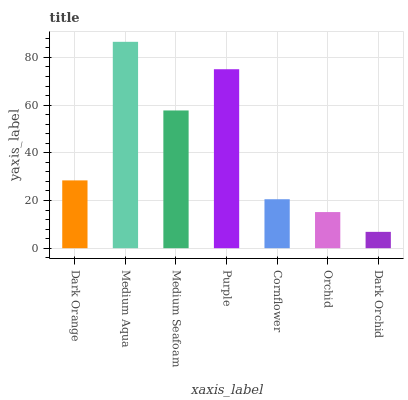Is Dark Orchid the minimum?
Answer yes or no. Yes. Is Medium Aqua the maximum?
Answer yes or no. Yes. Is Medium Seafoam the minimum?
Answer yes or no. No. Is Medium Seafoam the maximum?
Answer yes or no. No. Is Medium Aqua greater than Medium Seafoam?
Answer yes or no. Yes. Is Medium Seafoam less than Medium Aqua?
Answer yes or no. Yes. Is Medium Seafoam greater than Medium Aqua?
Answer yes or no. No. Is Medium Aqua less than Medium Seafoam?
Answer yes or no. No. Is Dark Orange the high median?
Answer yes or no. Yes. Is Dark Orange the low median?
Answer yes or no. Yes. Is Dark Orchid the high median?
Answer yes or no. No. Is Purple the low median?
Answer yes or no. No. 